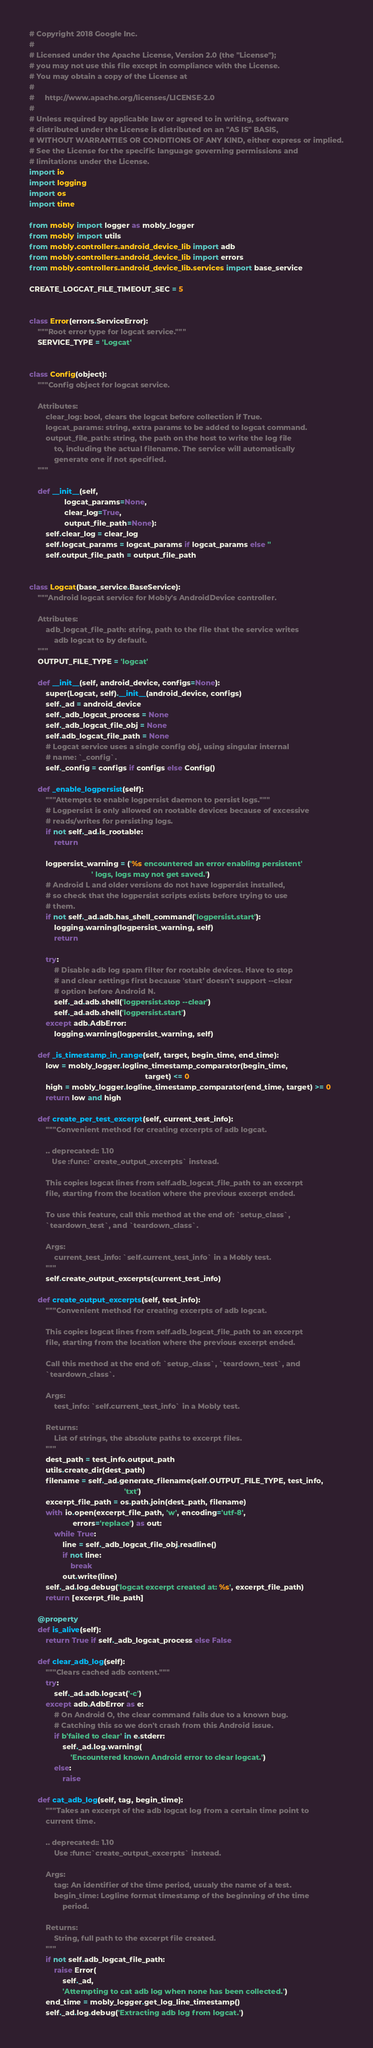<code> <loc_0><loc_0><loc_500><loc_500><_Python_># Copyright 2018 Google Inc.
#
# Licensed under the Apache License, Version 2.0 (the "License");
# you may not use this file except in compliance with the License.
# You may obtain a copy of the License at
#
#     http://www.apache.org/licenses/LICENSE-2.0
#
# Unless required by applicable law or agreed to in writing, software
# distributed under the License is distributed on an "AS IS" BASIS,
# WITHOUT WARRANTIES OR CONDITIONS OF ANY KIND, either express or implied.
# See the License for the specific language governing permissions and
# limitations under the License.
import io
import logging
import os
import time

from mobly import logger as mobly_logger
from mobly import utils
from mobly.controllers.android_device_lib import adb
from mobly.controllers.android_device_lib import errors
from mobly.controllers.android_device_lib.services import base_service

CREATE_LOGCAT_FILE_TIMEOUT_SEC = 5


class Error(errors.ServiceError):
    """Root error type for logcat service."""
    SERVICE_TYPE = 'Logcat'


class Config(object):
    """Config object for logcat service.

    Attributes:
        clear_log: bool, clears the logcat before collection if True.
        logcat_params: string, extra params to be added to logcat command.
        output_file_path: string, the path on the host to write the log file
            to, including the actual filename. The service will automatically
            generate one if not specified.
    """

    def __init__(self,
                 logcat_params=None,
                 clear_log=True,
                 output_file_path=None):
        self.clear_log = clear_log
        self.logcat_params = logcat_params if logcat_params else ''
        self.output_file_path = output_file_path


class Logcat(base_service.BaseService):
    """Android logcat service for Mobly's AndroidDevice controller.

    Attributes:
        adb_logcat_file_path: string, path to the file that the service writes
            adb logcat to by default.
    """
    OUTPUT_FILE_TYPE = 'logcat'

    def __init__(self, android_device, configs=None):
        super(Logcat, self).__init__(android_device, configs)
        self._ad = android_device
        self._adb_logcat_process = None
        self._adb_logcat_file_obj = None
        self.adb_logcat_file_path = None
        # Logcat service uses a single config obj, using singular internal
        # name: `_config`.
        self._config = configs if configs else Config()

    def _enable_logpersist(self):
        """Attempts to enable logpersist daemon to persist logs."""
        # Logpersist is only allowed on rootable devices because of excessive
        # reads/writes for persisting logs.
        if not self._ad.is_rootable:
            return

        logpersist_warning = ('%s encountered an error enabling persistent'
                              ' logs, logs may not get saved.')
        # Android L and older versions do not have logpersist installed,
        # so check that the logpersist scripts exists before trying to use
        # them.
        if not self._ad.adb.has_shell_command('logpersist.start'):
            logging.warning(logpersist_warning, self)
            return

        try:
            # Disable adb log spam filter for rootable devices. Have to stop
            # and clear settings first because 'start' doesn't support --clear
            # option before Android N.
            self._ad.adb.shell('logpersist.stop --clear')
            self._ad.adb.shell('logpersist.start')
        except adb.AdbError:
            logging.warning(logpersist_warning, self)

    def _is_timestamp_in_range(self, target, begin_time, end_time):
        low = mobly_logger.logline_timestamp_comparator(begin_time,
                                                        target) <= 0
        high = mobly_logger.logline_timestamp_comparator(end_time, target) >= 0
        return low and high

    def create_per_test_excerpt(self, current_test_info):
        """Convenient method for creating excerpts of adb logcat.

        .. deprecated:: 1.10
           Use :func:`create_output_excerpts` instead.

        This copies logcat lines from self.adb_logcat_file_path to an excerpt
        file, starting from the location where the previous excerpt ended.

        To use this feature, call this method at the end of: `setup_class`,
        `teardown_test`, and `teardown_class`.

        Args:
            current_test_info: `self.current_test_info` in a Mobly test.
        """
        self.create_output_excerpts(current_test_info)

    def create_output_excerpts(self, test_info):
        """Convenient method for creating excerpts of adb logcat.

        This copies logcat lines from self.adb_logcat_file_path to an excerpt
        file, starting from the location where the previous excerpt ended.

        Call this method at the end of: `setup_class`, `teardown_test`, and
        `teardown_class`.

        Args:
            test_info: `self.current_test_info` in a Mobly test.

        Returns:
            List of strings, the absolute paths to excerpt files.
        """
        dest_path = test_info.output_path
        utils.create_dir(dest_path)
        filename = self._ad.generate_filename(self.OUTPUT_FILE_TYPE, test_info,
                                              'txt')
        excerpt_file_path = os.path.join(dest_path, filename)
        with io.open(excerpt_file_path, 'w', encoding='utf-8',
                     errors='replace') as out:
            while True:
                line = self._adb_logcat_file_obj.readline()
                if not line:
                    break
                out.write(line)
        self._ad.log.debug('logcat excerpt created at: %s', excerpt_file_path)
        return [excerpt_file_path]

    @property
    def is_alive(self):
        return True if self._adb_logcat_process else False

    def clear_adb_log(self):
        """Clears cached adb content."""
        try:
            self._ad.adb.logcat('-c')
        except adb.AdbError as e:
            # On Android O, the clear command fails due to a known bug.
            # Catching this so we don't crash from this Android issue.
            if b'failed to clear' in e.stderr:
                self._ad.log.warning(
                    'Encountered known Android error to clear logcat.')
            else:
                raise

    def cat_adb_log(self, tag, begin_time):
        """Takes an excerpt of the adb logcat log from a certain time point to
        current time.

        .. deprecated:: 1.10
            Use :func:`create_output_excerpts` instead.

        Args:
            tag: An identifier of the time period, usualy the name of a test.
            begin_time: Logline format timestamp of the beginning of the time
                period.

        Returns:
            String, full path to the excerpt file created.
        """
        if not self.adb_logcat_file_path:
            raise Error(
                self._ad,
                'Attempting to cat adb log when none has been collected.')
        end_time = mobly_logger.get_log_line_timestamp()
        self._ad.log.debug('Extracting adb log from logcat.')</code> 